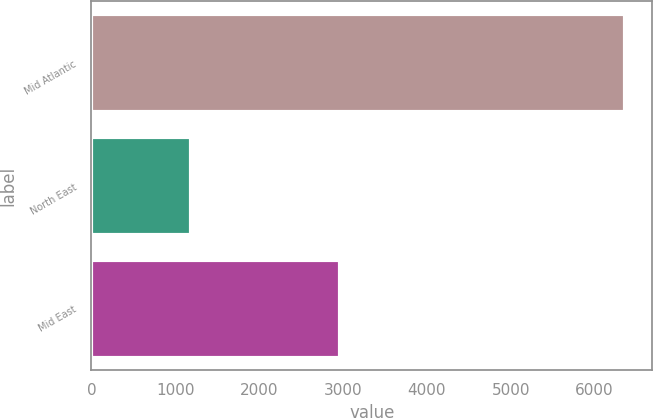Convert chart. <chart><loc_0><loc_0><loc_500><loc_500><bar_chart><fcel>Mid Atlantic<fcel>North East<fcel>Mid East<nl><fcel>6365<fcel>1182<fcel>2963<nl></chart> 